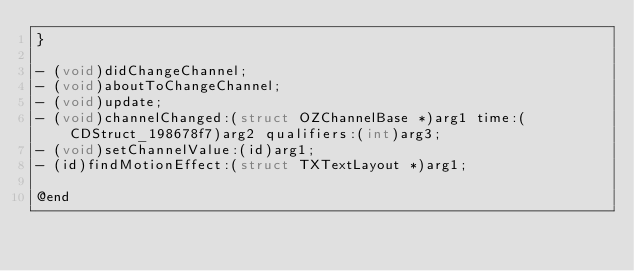<code> <loc_0><loc_0><loc_500><loc_500><_C_>}

- (void)didChangeChannel;
- (void)aboutToChangeChannel;
- (void)update;
- (void)channelChanged:(struct OZChannelBase *)arg1 time:(CDStruct_198678f7)arg2 qualifiers:(int)arg3;
- (void)setChannelValue:(id)arg1;
- (id)findMotionEffect:(struct TXTextLayout *)arg1;

@end

</code> 